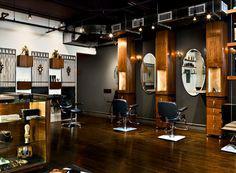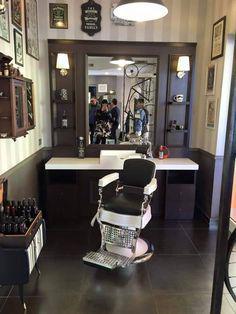The first image is the image on the left, the second image is the image on the right. Examine the images to the left and right. Is the description "There is at least five people's reflections in the mirror." accurate? Answer yes or no. Yes. The first image is the image on the left, the second image is the image on the right. Assess this claim about the two images: "There is only one barber chair in the left image.". Correct or not? Answer yes or no. No. 